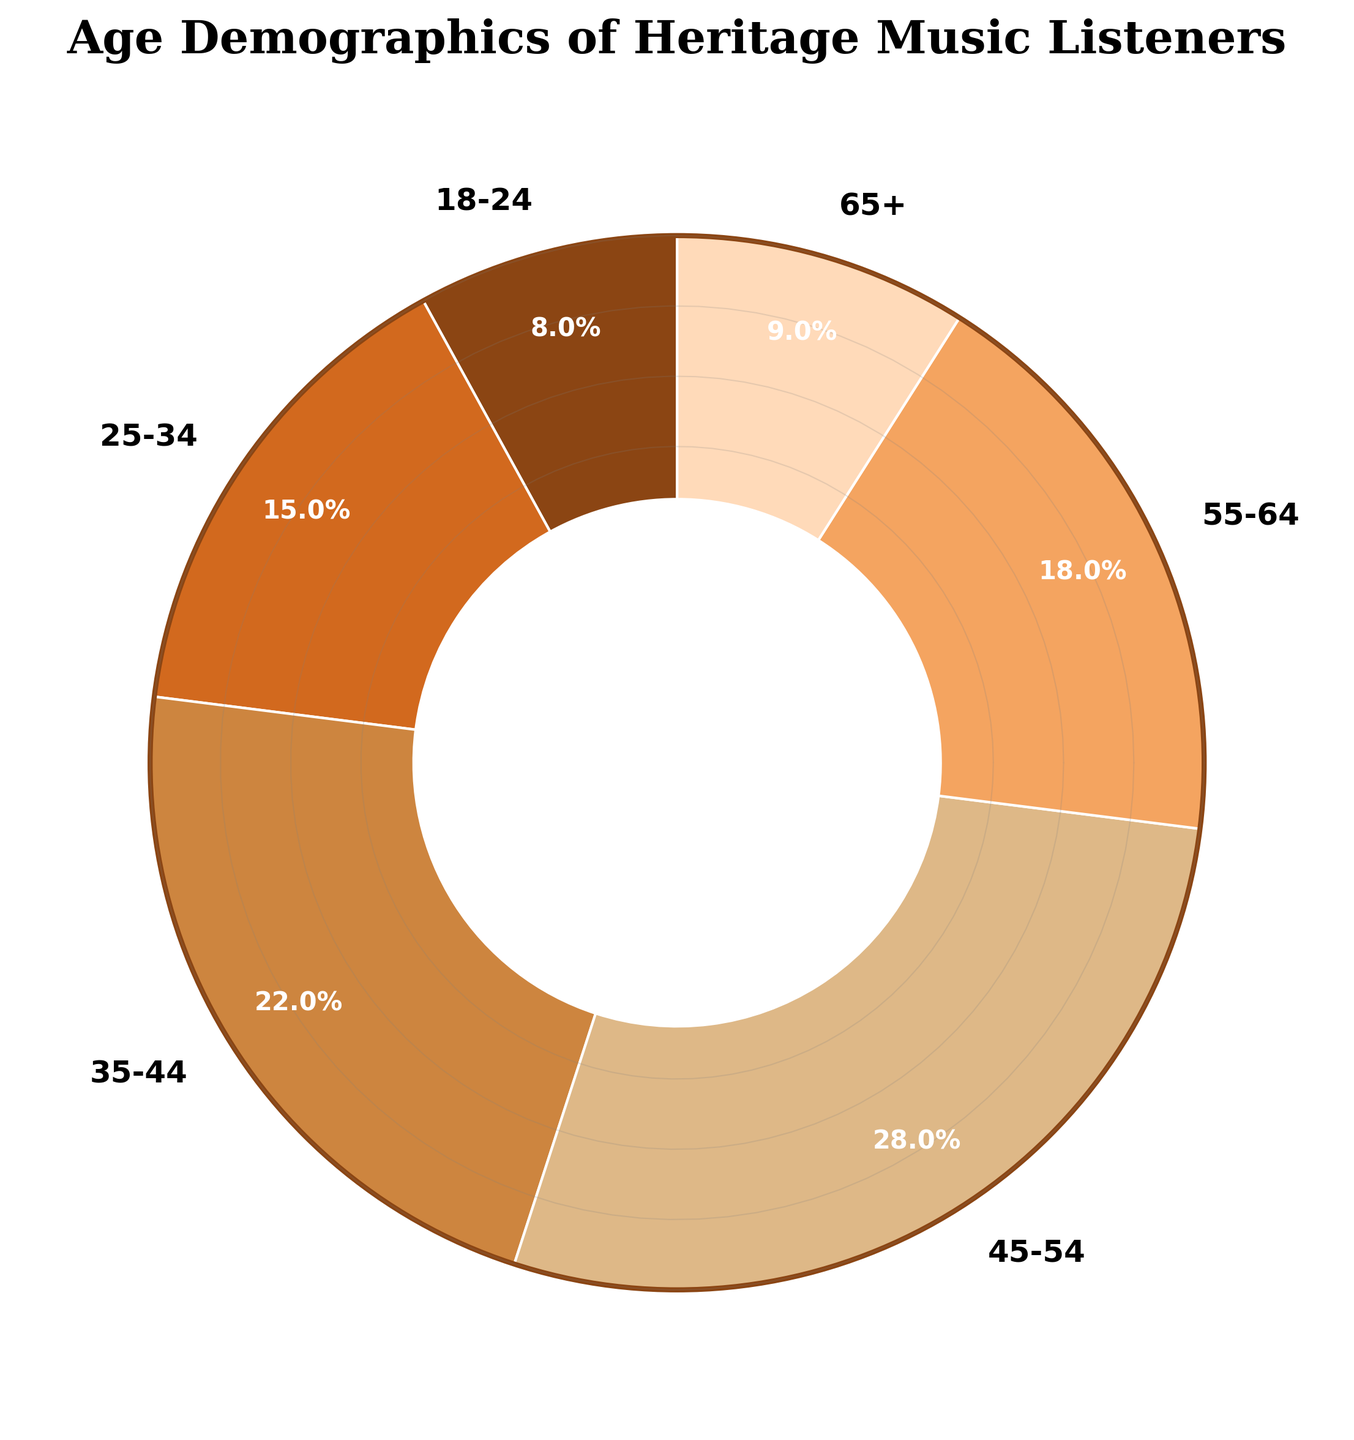What age group has the highest percentage of heritage music listeners? The age group with the highest percentage is indicated by the largest wedge in the pie chart, which is labeled 45-54.
Answer: 45-54 How much larger is the percentage of listeners aged 35-44 compared to those aged 18-24? The percentage for 35-44 is 22%, and for 18-24 is 8%. The difference is calculated as 22% - 8% = 14%.
Answer: 14% What is the combined percentage of listeners aged 45-54 and 55-64? The percentage for 45-54 is 28%, and for 55-64 is 18%. Their combined percentage is 28% + 18% = 46%.
Answer: 46% Which age group has nearly the same percentage as those aged 18-24? The percentages for each age group are visually indicated on the chart, with those aged 65+ having a similar percentage to the 18-24 group. Both groups have close percentages (9% for 65+ and 8% for 18-24).
Answer: 65+ What is the average percentage of listeners in the age groups 35-44 and 25-34? The percentages for the groups are 22% for 35-44 and 15% for 25-34. The average is calculated by (22% + 15%) / 2 = 18.5%.
Answer: 18.5% Compare the percentage of listeners aged 25-34 with those aged 55-64. Which is higher? Look at the pie chart for the comparative sizes of the wedges. The percentage for 55-64 (18%) is higher than for 25-34 (15%).
Answer: 55-64 What is the total percentage of listeners under the age of 35? The age groups under 35 are 18-24 and 25-34. The percentages are 8% and 15%, respectively. Therefore, the total percentage is 8% + 15% = 23%.
Answer: 23% What is the difference between the percentages of the youngest and oldest listener groups? The youngest group (18-24) has 8%, and the oldest group (65+) has 9%. The difference is calculated as 9% - 8% = 1%.
Answer: 1% Between the age groups 35-44 and 45-54, which one has a darker wedge color in the pie chart? The wedge colors are visually distinguishable, with the 45-54 age group having a darker shade (a more intense brown) than the 35-44 age group.
Answer: 45-54 What percentage of the listeners are aged 35 and above? The age groups 35 and above are 35-44, 45-54, 55-64, and 65+. Their respective percentages are 22%, 28%, 18%, and 9%. The total is 22% + 28% + 18% + 9% = 77%.
Answer: 77% 